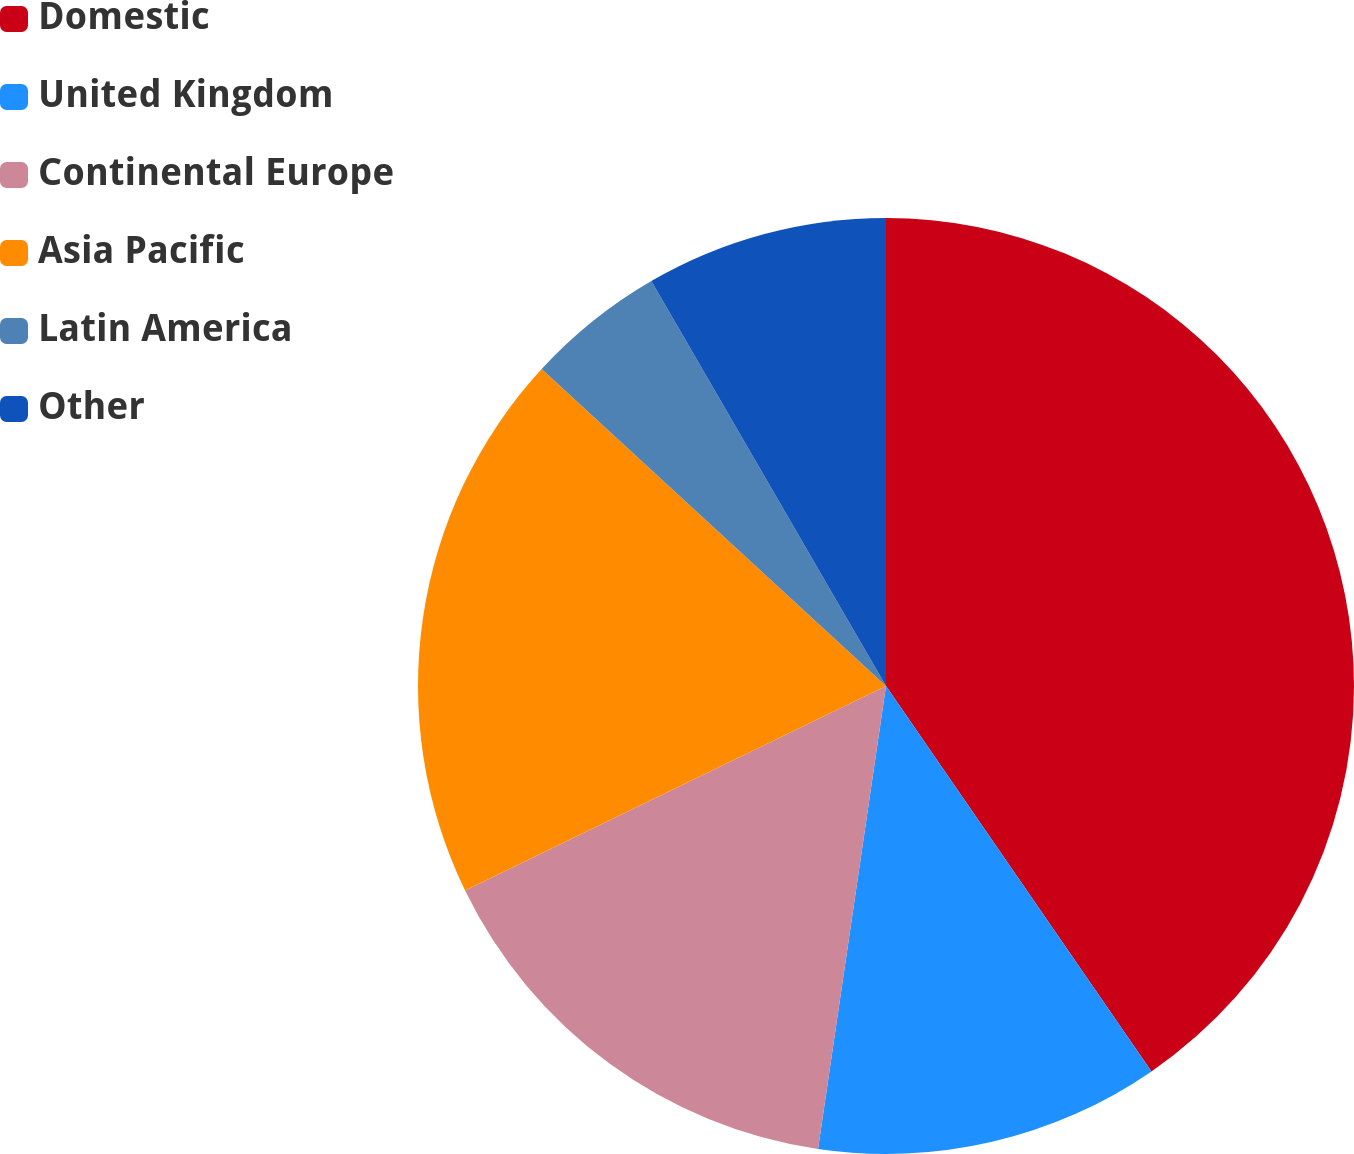Convert chart to OTSL. <chart><loc_0><loc_0><loc_500><loc_500><pie_chart><fcel>Domestic<fcel>United Kingdom<fcel>Continental Europe<fcel>Asia Pacific<fcel>Latin America<fcel>Other<nl><fcel>40.4%<fcel>11.92%<fcel>15.48%<fcel>19.04%<fcel>4.8%<fcel>8.36%<nl></chart> 